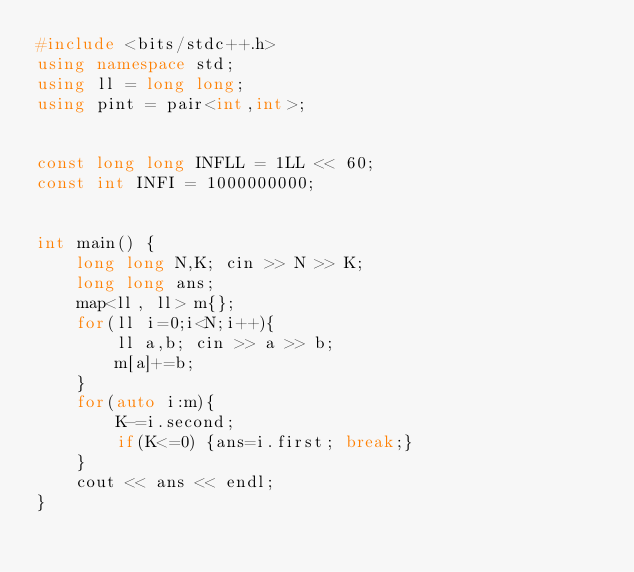Convert code to text. <code><loc_0><loc_0><loc_500><loc_500><_C++_>#include <bits/stdc++.h>
using namespace std;
using ll = long long;
using pint = pair<int,int>;


const long long INFLL = 1LL << 60;
const int INFI = 1000000000;


int main() {
    long long N,K; cin >> N >> K;
    long long ans;
    map<ll, ll> m{};
    for(ll i=0;i<N;i++){
        ll a,b; cin >> a >> b;
        m[a]+=b;
    }
    for(auto i:m){
        K-=i.second;
        if(K<=0) {ans=i.first; break;}
    }
    cout << ans << endl;
}

</code> 